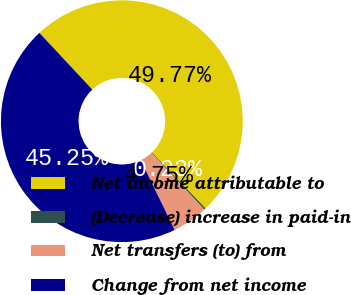Convert chart to OTSL. <chart><loc_0><loc_0><loc_500><loc_500><pie_chart><fcel>Net income attributable to<fcel>(Decrease) increase in paid-in<fcel>Net transfers (to) from<fcel>Change from net income<nl><fcel>49.77%<fcel>0.23%<fcel>4.75%<fcel>45.25%<nl></chart> 